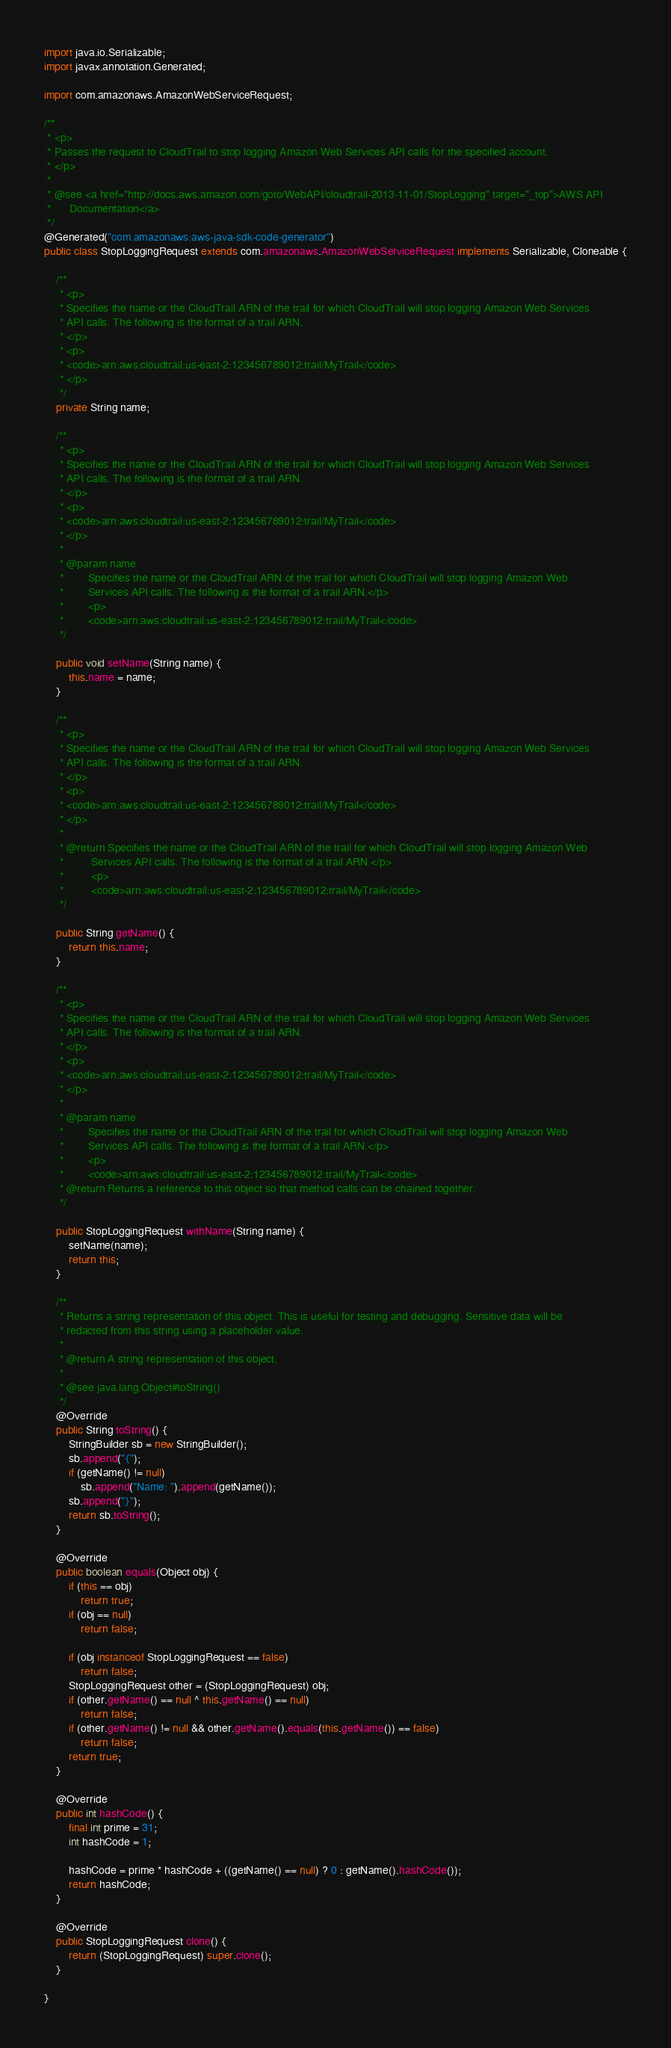<code> <loc_0><loc_0><loc_500><loc_500><_Java_>
import java.io.Serializable;
import javax.annotation.Generated;

import com.amazonaws.AmazonWebServiceRequest;

/**
 * <p>
 * Passes the request to CloudTrail to stop logging Amazon Web Services API calls for the specified account.
 * </p>
 * 
 * @see <a href="http://docs.aws.amazon.com/goto/WebAPI/cloudtrail-2013-11-01/StopLogging" target="_top">AWS API
 *      Documentation</a>
 */
@Generated("com.amazonaws:aws-java-sdk-code-generator")
public class StopLoggingRequest extends com.amazonaws.AmazonWebServiceRequest implements Serializable, Cloneable {

    /**
     * <p>
     * Specifies the name or the CloudTrail ARN of the trail for which CloudTrail will stop logging Amazon Web Services
     * API calls. The following is the format of a trail ARN.
     * </p>
     * <p>
     * <code>arn:aws:cloudtrail:us-east-2:123456789012:trail/MyTrail</code>
     * </p>
     */
    private String name;

    /**
     * <p>
     * Specifies the name or the CloudTrail ARN of the trail for which CloudTrail will stop logging Amazon Web Services
     * API calls. The following is the format of a trail ARN.
     * </p>
     * <p>
     * <code>arn:aws:cloudtrail:us-east-2:123456789012:trail/MyTrail</code>
     * </p>
     * 
     * @param name
     *        Specifies the name or the CloudTrail ARN of the trail for which CloudTrail will stop logging Amazon Web
     *        Services API calls. The following is the format of a trail ARN.</p>
     *        <p>
     *        <code>arn:aws:cloudtrail:us-east-2:123456789012:trail/MyTrail</code>
     */

    public void setName(String name) {
        this.name = name;
    }

    /**
     * <p>
     * Specifies the name or the CloudTrail ARN of the trail for which CloudTrail will stop logging Amazon Web Services
     * API calls. The following is the format of a trail ARN.
     * </p>
     * <p>
     * <code>arn:aws:cloudtrail:us-east-2:123456789012:trail/MyTrail</code>
     * </p>
     * 
     * @return Specifies the name or the CloudTrail ARN of the trail for which CloudTrail will stop logging Amazon Web
     *         Services API calls. The following is the format of a trail ARN.</p>
     *         <p>
     *         <code>arn:aws:cloudtrail:us-east-2:123456789012:trail/MyTrail</code>
     */

    public String getName() {
        return this.name;
    }

    /**
     * <p>
     * Specifies the name or the CloudTrail ARN of the trail for which CloudTrail will stop logging Amazon Web Services
     * API calls. The following is the format of a trail ARN.
     * </p>
     * <p>
     * <code>arn:aws:cloudtrail:us-east-2:123456789012:trail/MyTrail</code>
     * </p>
     * 
     * @param name
     *        Specifies the name or the CloudTrail ARN of the trail for which CloudTrail will stop logging Amazon Web
     *        Services API calls. The following is the format of a trail ARN.</p>
     *        <p>
     *        <code>arn:aws:cloudtrail:us-east-2:123456789012:trail/MyTrail</code>
     * @return Returns a reference to this object so that method calls can be chained together.
     */

    public StopLoggingRequest withName(String name) {
        setName(name);
        return this;
    }

    /**
     * Returns a string representation of this object. This is useful for testing and debugging. Sensitive data will be
     * redacted from this string using a placeholder value.
     *
     * @return A string representation of this object.
     *
     * @see java.lang.Object#toString()
     */
    @Override
    public String toString() {
        StringBuilder sb = new StringBuilder();
        sb.append("{");
        if (getName() != null)
            sb.append("Name: ").append(getName());
        sb.append("}");
        return sb.toString();
    }

    @Override
    public boolean equals(Object obj) {
        if (this == obj)
            return true;
        if (obj == null)
            return false;

        if (obj instanceof StopLoggingRequest == false)
            return false;
        StopLoggingRequest other = (StopLoggingRequest) obj;
        if (other.getName() == null ^ this.getName() == null)
            return false;
        if (other.getName() != null && other.getName().equals(this.getName()) == false)
            return false;
        return true;
    }

    @Override
    public int hashCode() {
        final int prime = 31;
        int hashCode = 1;

        hashCode = prime * hashCode + ((getName() == null) ? 0 : getName().hashCode());
        return hashCode;
    }

    @Override
    public StopLoggingRequest clone() {
        return (StopLoggingRequest) super.clone();
    }

}
</code> 